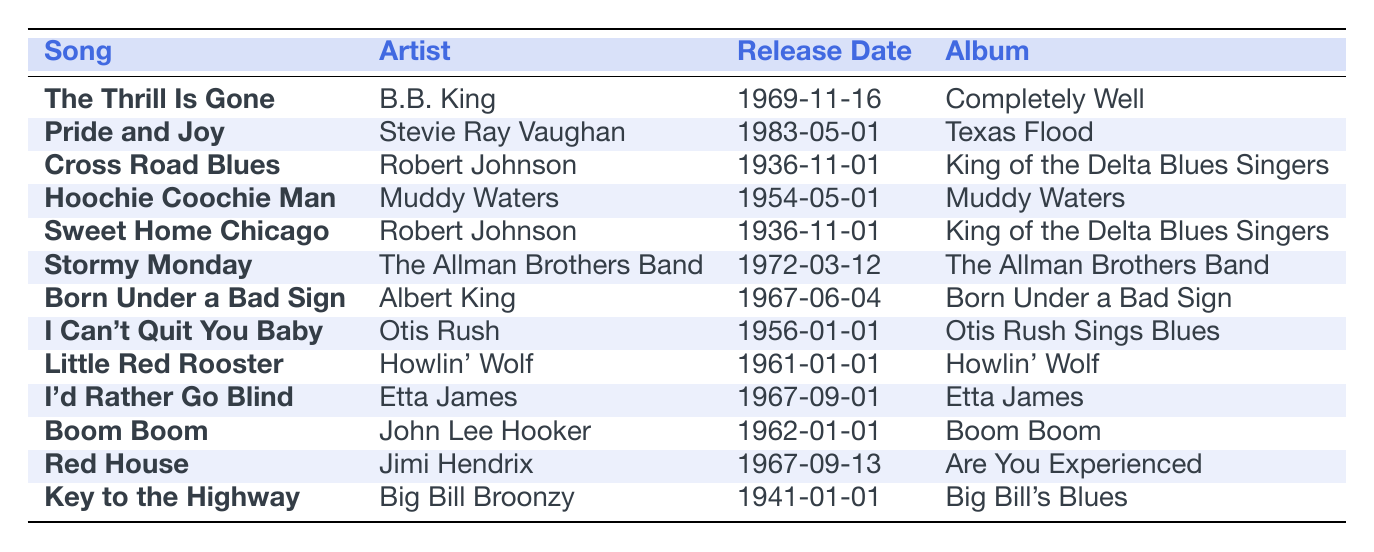What artist performed "The Thrill Is Gone"? The table lists "The Thrill Is Gone" under the song column and shows "B.B. King" in the corresponding artist column.
Answer: B.B. King Which song was released on January 1, 1961? By scanning the release date column for January 1, 1961, we find that "Little Red Rooster" appears in the song column.
Answer: Little Red Rooster How many songs were released in the 1960s? To find the count, we look at all the songs with release dates from the 1960s: "The Thrill Is Gone" (1969), "Born Under a Bad Sign" (1967), "I'd Rather Go Blind" (1967), "Boom Boom" (1962), "Little Red Rooster" (1961), and "Red House" (1967). There are 6 songs in total.
Answer: 6 Is "Pride and Joy" the only song by Stevie Ray Vaughan listed? Checking the table, "Pride and Joy" is the only song listed under Stevie Ray Vaughan in the artist column, indicating it is indeed the only one.
Answer: Yes What is the average release year of the songs listed in the table? Identifying the release years from the table: 1936, 1941, 1954, 1956, 1961, 1962, 1967, 1967, 1969, 1972, 1983. To find the average, sum these years (1936 + 1941 + 1954 + 1956 + 1961 + 1962 + 1967 + 1967 + 1969 + 1972 + 1983 = 21872) and divide by the number of songs (11). Thus, 21872 / 11 = 1988.36, rounding down gives us 1988.
Answer: 1988 